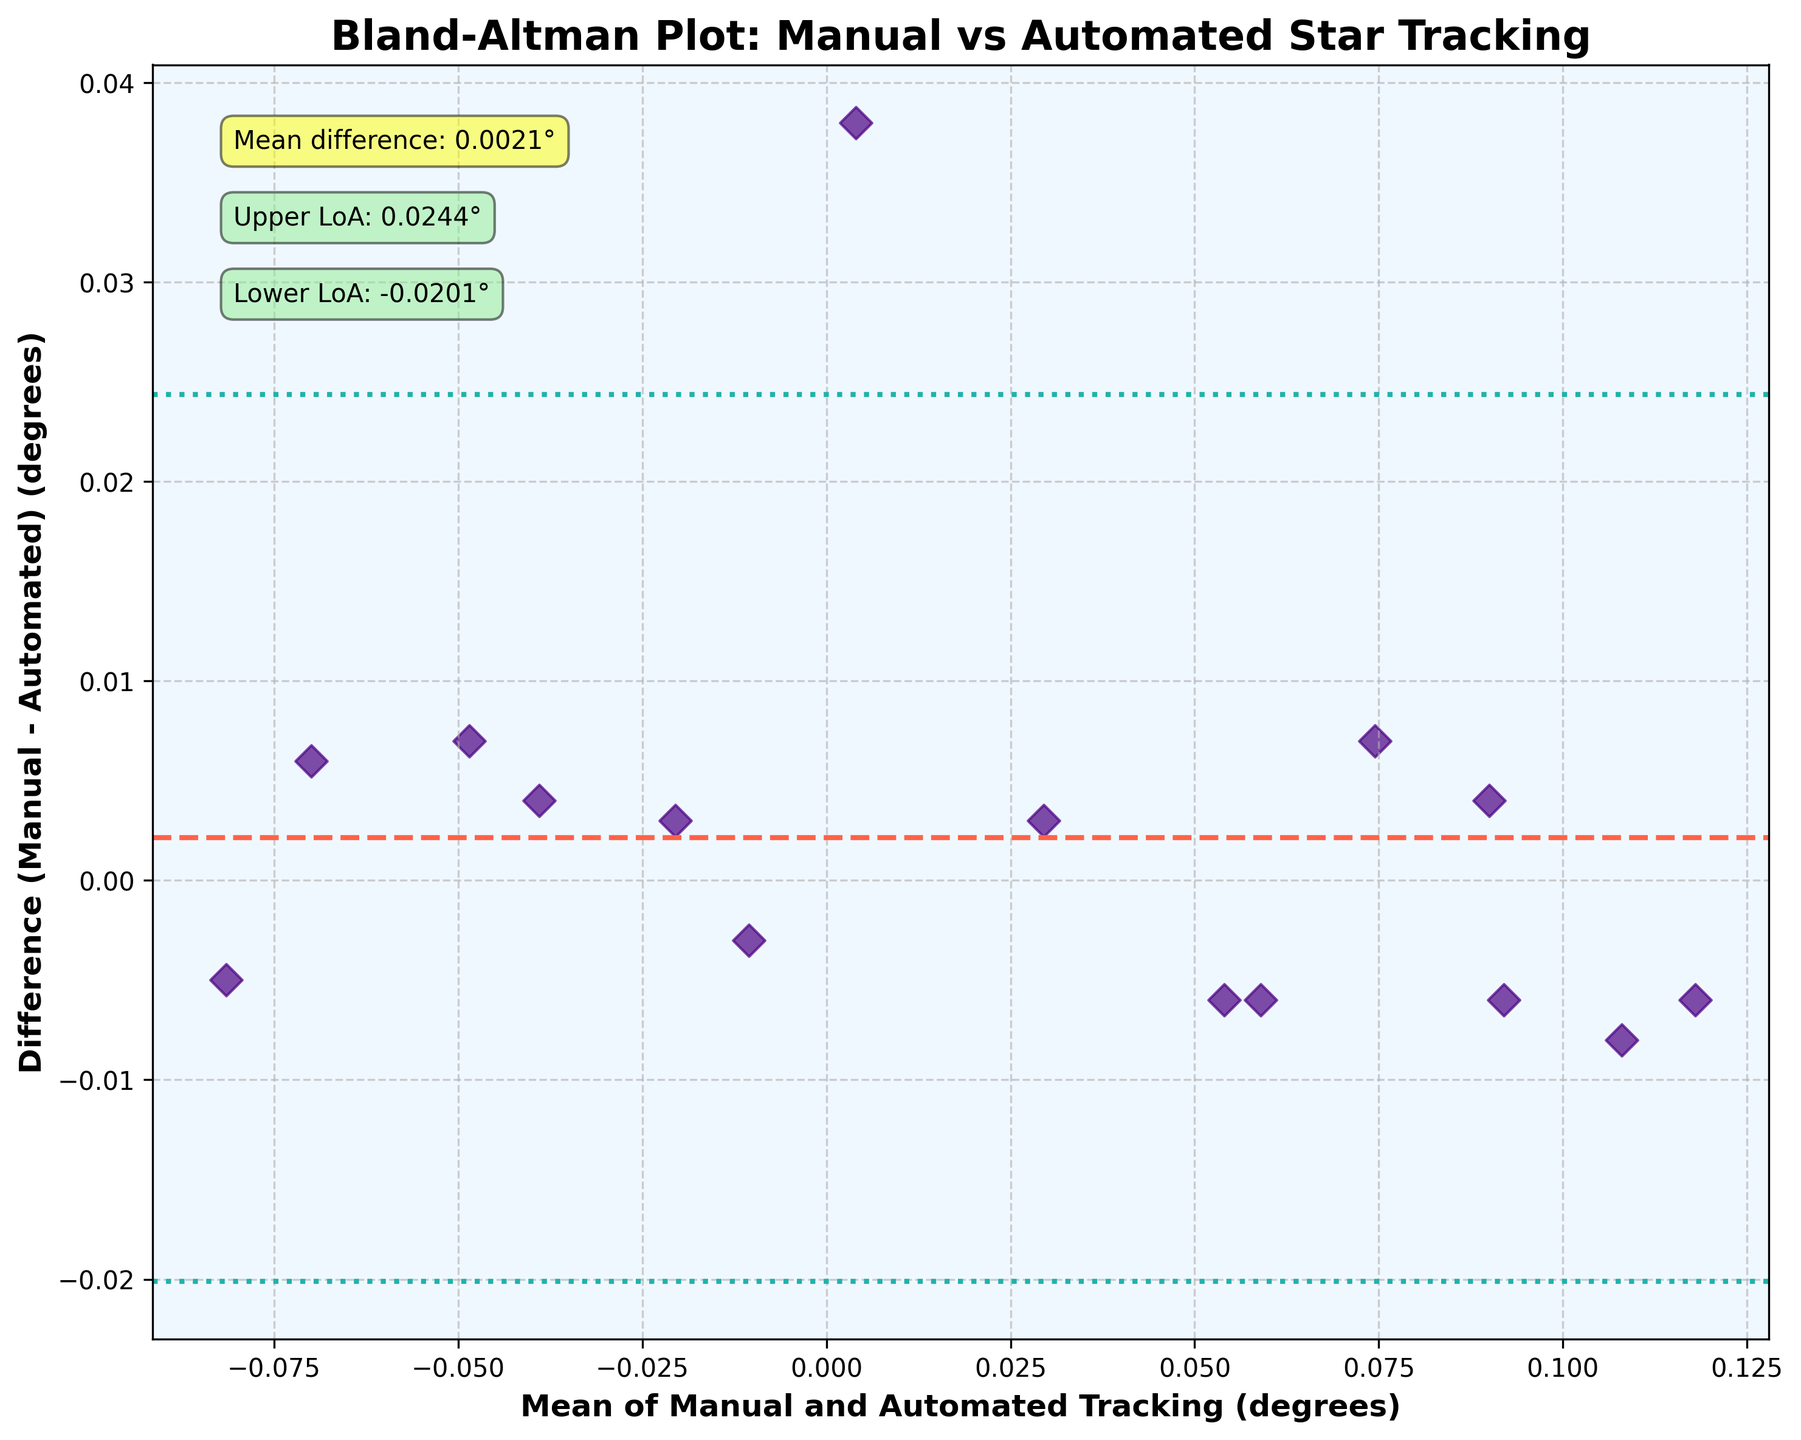What is the title of the plot? The title of the plot is displayed at the top of the Bland-Altman plot. It clearly indicates the focus of the analysis.
Answer: Bland-Altman Plot: Manual vs Automated Star Tracking How many data points are plotted on the Bland-Altman plot? The data points are represented by scatter points in the plot. By counting these points, we can determine their total number.
Answer: 15 What is the color of the scatter points representing the data? The color of the scatter points can be identified by looking at the plot and observing their common color.
Answer: Purple What is the mean difference between Manual and Automated Tracking? The mean difference is indicated on the plot as a horizontal dashed line, accompanied by an annotation that specifies its value.
Answer: 0.0011° What are the upper and lower limits of agreement? The upper and lower limits of agreement are marked by dotted lines on the plot. Additionally, they are annotated on the plot for clarity.
Answer: Upper LoA: 0.0368°, Lower LoA: -0.0346° What is the difference between the highest and lowest data points? Observing the vertical spread of the scatter points, the highest data point can be identified as approximately 0.03 and the lowest as roughly -0.05. The difference between these points is calculated as 0.03 - (-0.05).
Answer: 0.08° Is the mean difference line above or below the x-axis? By looking at the horizontal dashed line representing the mean difference and its position relative to the x-axis, we can determine if it is above or below.
Answer: Above Are there any data points outside the limits of agreement? Checking if any scatter points lie beyond the dotted lines that represent the limits of agreement will answer this question.
Answer: No Which axis represents the Mean of Manual and Automated Tracking? By reading the axis labels, we can determine which axis corresponds to the Mean of Manual and Automated Tracking.
Answer: X-axis Which axis represents the Difference (Manual - Automated)? By reading the axis labels, we can identify which axis corresponds to the Difference (Manual - Automated).
Answer: Y-axis 